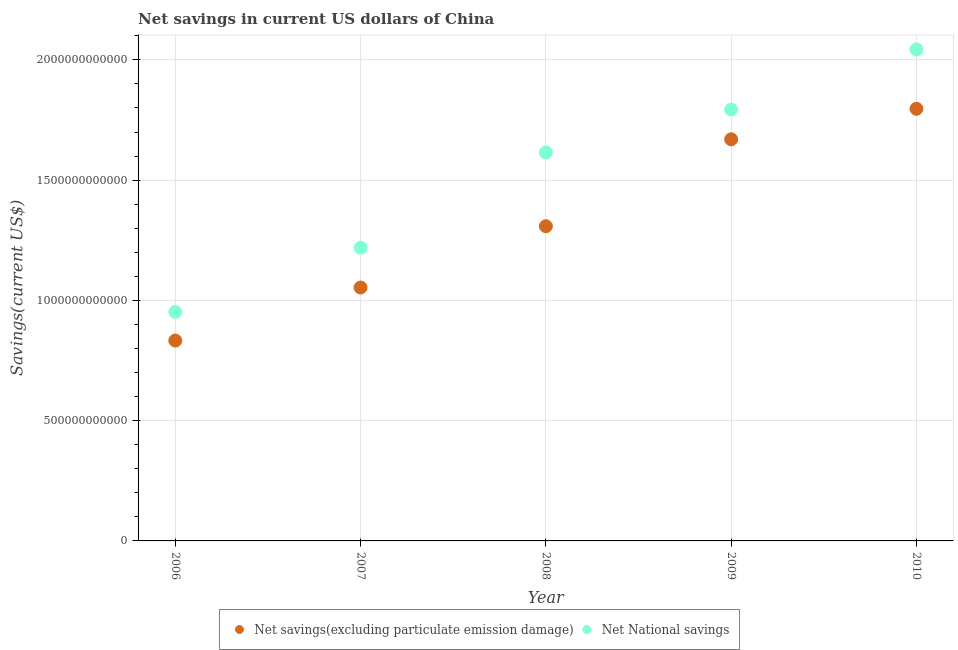Is the number of dotlines equal to the number of legend labels?
Offer a terse response. Yes. What is the net savings(excluding particulate emission damage) in 2006?
Keep it short and to the point. 8.33e+11. Across all years, what is the maximum net national savings?
Make the answer very short. 2.04e+12. Across all years, what is the minimum net national savings?
Give a very brief answer. 9.52e+11. In which year was the net savings(excluding particulate emission damage) minimum?
Keep it short and to the point. 2006. What is the total net national savings in the graph?
Your answer should be compact. 7.62e+12. What is the difference between the net savings(excluding particulate emission damage) in 2007 and that in 2009?
Provide a succinct answer. -6.16e+11. What is the difference between the net national savings in 2009 and the net savings(excluding particulate emission damage) in 2008?
Your answer should be compact. 4.85e+11. What is the average net savings(excluding particulate emission damage) per year?
Provide a succinct answer. 1.33e+12. In the year 2009, what is the difference between the net national savings and net savings(excluding particulate emission damage)?
Make the answer very short. 1.24e+11. In how many years, is the net savings(excluding particulate emission damage) greater than 1500000000000 US$?
Ensure brevity in your answer.  2. What is the ratio of the net national savings in 2006 to that in 2008?
Keep it short and to the point. 0.59. Is the net savings(excluding particulate emission damage) in 2008 less than that in 2009?
Make the answer very short. Yes. Is the difference between the net savings(excluding particulate emission damage) in 2008 and 2009 greater than the difference between the net national savings in 2008 and 2009?
Your answer should be very brief. No. What is the difference between the highest and the second highest net national savings?
Provide a succinct answer. 2.50e+11. What is the difference between the highest and the lowest net national savings?
Offer a terse response. 1.09e+12. Does the net savings(excluding particulate emission damage) monotonically increase over the years?
Your answer should be compact. Yes. Is the net national savings strictly less than the net savings(excluding particulate emission damage) over the years?
Your answer should be very brief. No. How many dotlines are there?
Make the answer very short. 2. How many years are there in the graph?
Offer a very short reply. 5. What is the difference between two consecutive major ticks on the Y-axis?
Make the answer very short. 5.00e+11. Are the values on the major ticks of Y-axis written in scientific E-notation?
Offer a very short reply. No. How many legend labels are there?
Ensure brevity in your answer.  2. How are the legend labels stacked?
Your response must be concise. Horizontal. What is the title of the graph?
Give a very brief answer. Net savings in current US dollars of China. What is the label or title of the X-axis?
Provide a short and direct response. Year. What is the label or title of the Y-axis?
Offer a very short reply. Savings(current US$). What is the Savings(current US$) in Net savings(excluding particulate emission damage) in 2006?
Your answer should be compact. 8.33e+11. What is the Savings(current US$) in Net National savings in 2006?
Provide a short and direct response. 9.52e+11. What is the Savings(current US$) of Net savings(excluding particulate emission damage) in 2007?
Keep it short and to the point. 1.05e+12. What is the Savings(current US$) in Net National savings in 2007?
Offer a very short reply. 1.22e+12. What is the Savings(current US$) of Net savings(excluding particulate emission damage) in 2008?
Provide a succinct answer. 1.31e+12. What is the Savings(current US$) of Net National savings in 2008?
Provide a succinct answer. 1.62e+12. What is the Savings(current US$) of Net savings(excluding particulate emission damage) in 2009?
Make the answer very short. 1.67e+12. What is the Savings(current US$) in Net National savings in 2009?
Give a very brief answer. 1.79e+12. What is the Savings(current US$) of Net savings(excluding particulate emission damage) in 2010?
Offer a terse response. 1.80e+12. What is the Savings(current US$) of Net National savings in 2010?
Give a very brief answer. 2.04e+12. Across all years, what is the maximum Savings(current US$) of Net savings(excluding particulate emission damage)?
Your response must be concise. 1.80e+12. Across all years, what is the maximum Savings(current US$) in Net National savings?
Offer a terse response. 2.04e+12. Across all years, what is the minimum Savings(current US$) of Net savings(excluding particulate emission damage)?
Offer a terse response. 8.33e+11. Across all years, what is the minimum Savings(current US$) of Net National savings?
Offer a very short reply. 9.52e+11. What is the total Savings(current US$) of Net savings(excluding particulate emission damage) in the graph?
Make the answer very short. 6.66e+12. What is the total Savings(current US$) in Net National savings in the graph?
Your response must be concise. 7.62e+12. What is the difference between the Savings(current US$) of Net savings(excluding particulate emission damage) in 2006 and that in 2007?
Offer a terse response. -2.21e+11. What is the difference between the Savings(current US$) of Net National savings in 2006 and that in 2007?
Give a very brief answer. -2.67e+11. What is the difference between the Savings(current US$) of Net savings(excluding particulate emission damage) in 2006 and that in 2008?
Provide a short and direct response. -4.76e+11. What is the difference between the Savings(current US$) in Net National savings in 2006 and that in 2008?
Your answer should be very brief. -6.63e+11. What is the difference between the Savings(current US$) in Net savings(excluding particulate emission damage) in 2006 and that in 2009?
Provide a succinct answer. -8.37e+11. What is the difference between the Savings(current US$) in Net National savings in 2006 and that in 2009?
Provide a short and direct response. -8.42e+11. What is the difference between the Savings(current US$) of Net savings(excluding particulate emission damage) in 2006 and that in 2010?
Your answer should be compact. -9.64e+11. What is the difference between the Savings(current US$) in Net National savings in 2006 and that in 2010?
Ensure brevity in your answer.  -1.09e+12. What is the difference between the Savings(current US$) of Net savings(excluding particulate emission damage) in 2007 and that in 2008?
Offer a very short reply. -2.55e+11. What is the difference between the Savings(current US$) in Net National savings in 2007 and that in 2008?
Ensure brevity in your answer.  -3.96e+11. What is the difference between the Savings(current US$) in Net savings(excluding particulate emission damage) in 2007 and that in 2009?
Offer a terse response. -6.16e+11. What is the difference between the Savings(current US$) of Net National savings in 2007 and that in 2009?
Offer a very short reply. -5.75e+11. What is the difference between the Savings(current US$) of Net savings(excluding particulate emission damage) in 2007 and that in 2010?
Your answer should be compact. -7.43e+11. What is the difference between the Savings(current US$) of Net National savings in 2007 and that in 2010?
Make the answer very short. -8.24e+11. What is the difference between the Savings(current US$) in Net savings(excluding particulate emission damage) in 2008 and that in 2009?
Make the answer very short. -3.61e+11. What is the difference between the Savings(current US$) of Net National savings in 2008 and that in 2009?
Your answer should be very brief. -1.78e+11. What is the difference between the Savings(current US$) in Net savings(excluding particulate emission damage) in 2008 and that in 2010?
Keep it short and to the point. -4.88e+11. What is the difference between the Savings(current US$) in Net National savings in 2008 and that in 2010?
Offer a very short reply. -4.28e+11. What is the difference between the Savings(current US$) in Net savings(excluding particulate emission damage) in 2009 and that in 2010?
Offer a very short reply. -1.27e+11. What is the difference between the Savings(current US$) in Net National savings in 2009 and that in 2010?
Keep it short and to the point. -2.50e+11. What is the difference between the Savings(current US$) of Net savings(excluding particulate emission damage) in 2006 and the Savings(current US$) of Net National savings in 2007?
Make the answer very short. -3.86e+11. What is the difference between the Savings(current US$) in Net savings(excluding particulate emission damage) in 2006 and the Savings(current US$) in Net National savings in 2008?
Your response must be concise. -7.82e+11. What is the difference between the Savings(current US$) of Net savings(excluding particulate emission damage) in 2006 and the Savings(current US$) of Net National savings in 2009?
Provide a succinct answer. -9.61e+11. What is the difference between the Savings(current US$) of Net savings(excluding particulate emission damage) in 2006 and the Savings(current US$) of Net National savings in 2010?
Offer a terse response. -1.21e+12. What is the difference between the Savings(current US$) of Net savings(excluding particulate emission damage) in 2007 and the Savings(current US$) of Net National savings in 2008?
Your response must be concise. -5.62e+11. What is the difference between the Savings(current US$) of Net savings(excluding particulate emission damage) in 2007 and the Savings(current US$) of Net National savings in 2009?
Offer a terse response. -7.40e+11. What is the difference between the Savings(current US$) of Net savings(excluding particulate emission damage) in 2007 and the Savings(current US$) of Net National savings in 2010?
Provide a short and direct response. -9.90e+11. What is the difference between the Savings(current US$) in Net savings(excluding particulate emission damage) in 2008 and the Savings(current US$) in Net National savings in 2009?
Provide a short and direct response. -4.85e+11. What is the difference between the Savings(current US$) in Net savings(excluding particulate emission damage) in 2008 and the Savings(current US$) in Net National savings in 2010?
Ensure brevity in your answer.  -7.35e+11. What is the difference between the Savings(current US$) of Net savings(excluding particulate emission damage) in 2009 and the Savings(current US$) of Net National savings in 2010?
Provide a short and direct response. -3.74e+11. What is the average Savings(current US$) of Net savings(excluding particulate emission damage) per year?
Ensure brevity in your answer.  1.33e+12. What is the average Savings(current US$) in Net National savings per year?
Your answer should be compact. 1.52e+12. In the year 2006, what is the difference between the Savings(current US$) of Net savings(excluding particulate emission damage) and Savings(current US$) of Net National savings?
Offer a very short reply. -1.19e+11. In the year 2007, what is the difference between the Savings(current US$) in Net savings(excluding particulate emission damage) and Savings(current US$) in Net National savings?
Ensure brevity in your answer.  -1.65e+11. In the year 2008, what is the difference between the Savings(current US$) in Net savings(excluding particulate emission damage) and Savings(current US$) in Net National savings?
Provide a short and direct response. -3.07e+11. In the year 2009, what is the difference between the Savings(current US$) in Net savings(excluding particulate emission damage) and Savings(current US$) in Net National savings?
Offer a very short reply. -1.24e+11. In the year 2010, what is the difference between the Savings(current US$) of Net savings(excluding particulate emission damage) and Savings(current US$) of Net National savings?
Give a very brief answer. -2.47e+11. What is the ratio of the Savings(current US$) of Net savings(excluding particulate emission damage) in 2006 to that in 2007?
Offer a very short reply. 0.79. What is the ratio of the Savings(current US$) in Net National savings in 2006 to that in 2007?
Provide a succinct answer. 0.78. What is the ratio of the Savings(current US$) of Net savings(excluding particulate emission damage) in 2006 to that in 2008?
Ensure brevity in your answer.  0.64. What is the ratio of the Savings(current US$) in Net National savings in 2006 to that in 2008?
Your answer should be compact. 0.59. What is the ratio of the Savings(current US$) of Net savings(excluding particulate emission damage) in 2006 to that in 2009?
Offer a terse response. 0.5. What is the ratio of the Savings(current US$) of Net National savings in 2006 to that in 2009?
Make the answer very short. 0.53. What is the ratio of the Savings(current US$) in Net savings(excluding particulate emission damage) in 2006 to that in 2010?
Offer a terse response. 0.46. What is the ratio of the Savings(current US$) in Net National savings in 2006 to that in 2010?
Your answer should be compact. 0.47. What is the ratio of the Savings(current US$) of Net savings(excluding particulate emission damage) in 2007 to that in 2008?
Your answer should be very brief. 0.81. What is the ratio of the Savings(current US$) in Net National savings in 2007 to that in 2008?
Give a very brief answer. 0.75. What is the ratio of the Savings(current US$) of Net savings(excluding particulate emission damage) in 2007 to that in 2009?
Offer a terse response. 0.63. What is the ratio of the Savings(current US$) in Net National savings in 2007 to that in 2009?
Your answer should be very brief. 0.68. What is the ratio of the Savings(current US$) of Net savings(excluding particulate emission damage) in 2007 to that in 2010?
Ensure brevity in your answer.  0.59. What is the ratio of the Savings(current US$) of Net National savings in 2007 to that in 2010?
Offer a very short reply. 0.6. What is the ratio of the Savings(current US$) in Net savings(excluding particulate emission damage) in 2008 to that in 2009?
Keep it short and to the point. 0.78. What is the ratio of the Savings(current US$) of Net National savings in 2008 to that in 2009?
Provide a succinct answer. 0.9. What is the ratio of the Savings(current US$) in Net savings(excluding particulate emission damage) in 2008 to that in 2010?
Offer a very short reply. 0.73. What is the ratio of the Savings(current US$) in Net National savings in 2008 to that in 2010?
Your response must be concise. 0.79. What is the ratio of the Savings(current US$) of Net savings(excluding particulate emission damage) in 2009 to that in 2010?
Provide a short and direct response. 0.93. What is the ratio of the Savings(current US$) in Net National savings in 2009 to that in 2010?
Provide a succinct answer. 0.88. What is the difference between the highest and the second highest Savings(current US$) in Net savings(excluding particulate emission damage)?
Keep it short and to the point. 1.27e+11. What is the difference between the highest and the second highest Savings(current US$) of Net National savings?
Ensure brevity in your answer.  2.50e+11. What is the difference between the highest and the lowest Savings(current US$) in Net savings(excluding particulate emission damage)?
Your answer should be compact. 9.64e+11. What is the difference between the highest and the lowest Savings(current US$) of Net National savings?
Give a very brief answer. 1.09e+12. 